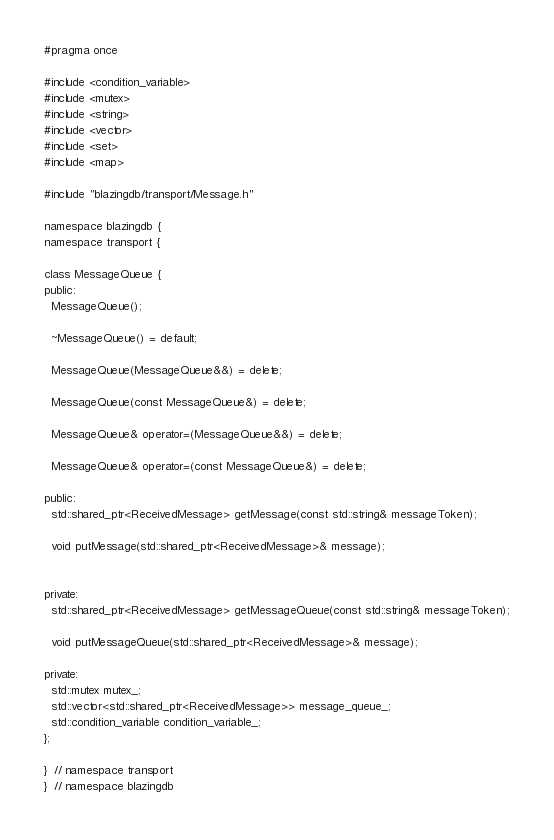<code> <loc_0><loc_0><loc_500><loc_500><_C_>#pragma once

#include <condition_variable>
#include <mutex>
#include <string>
#include <vector>
#include <set>
#include <map>

#include "blazingdb/transport/Message.h"

namespace blazingdb {
namespace transport {

class MessageQueue {
public:
  MessageQueue();

  ~MessageQueue() = default;

  MessageQueue(MessageQueue&&) = delete;

  MessageQueue(const MessageQueue&) = delete;

  MessageQueue& operator=(MessageQueue&&) = delete;

  MessageQueue& operator=(const MessageQueue&) = delete;

public:
  std::shared_ptr<ReceivedMessage> getMessage(const std::string& messageToken);

  void putMessage(std::shared_ptr<ReceivedMessage>& message);

  
private:
  std::shared_ptr<ReceivedMessage> getMessageQueue(const std::string& messageToken);

  void putMessageQueue(std::shared_ptr<ReceivedMessage>& message);

private:
  std::mutex mutex_;
  std::vector<std::shared_ptr<ReceivedMessage>> message_queue_;
  std::condition_variable condition_variable_;
};

}  // namespace transport
}  // namespace blazingdb
</code> 